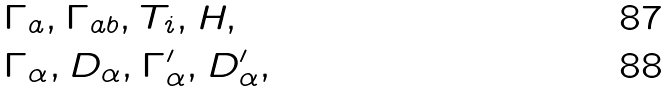Convert formula to latex. <formula><loc_0><loc_0><loc_500><loc_500>& \Gamma _ { a } , \Gamma _ { a b } , T _ { i } , H , \\ & \Gamma _ { \alpha } , D _ { \alpha } , \Gamma ^ { \prime } _ { \alpha } , D ^ { \prime } _ { \alpha } ,</formula> 